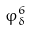<formula> <loc_0><loc_0><loc_500><loc_500>\varphi _ { \delta } ^ { 6 }</formula> 